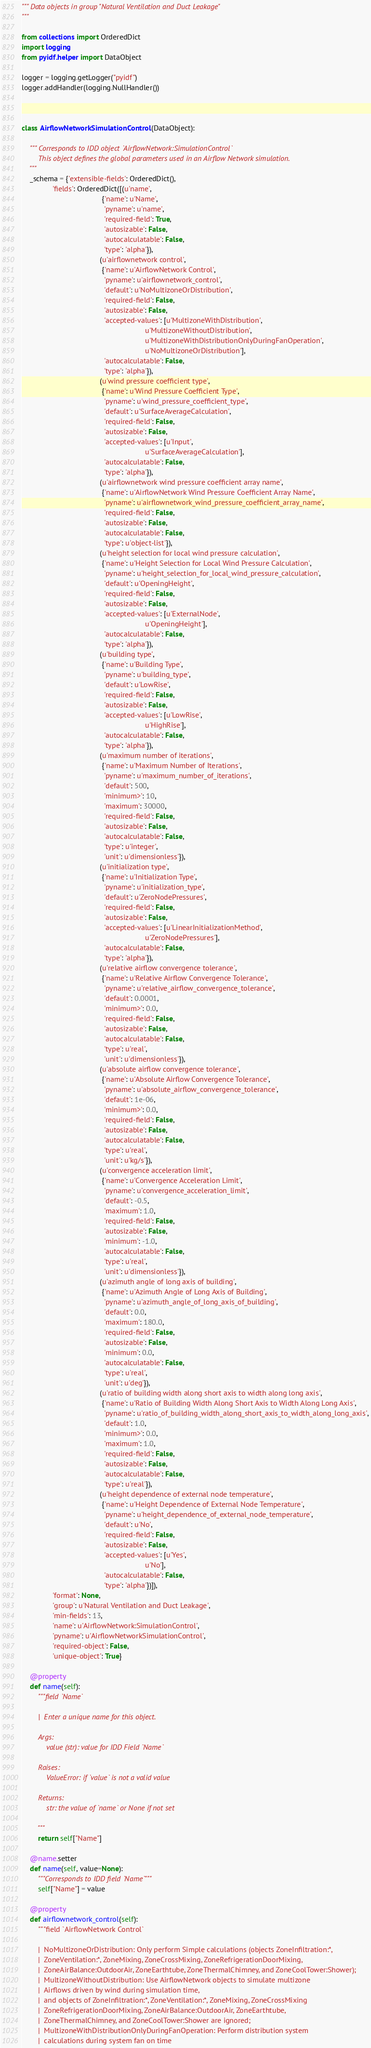<code> <loc_0><loc_0><loc_500><loc_500><_Python_>""" Data objects in group "Natural Ventilation and Duct Leakage"
"""

from collections import OrderedDict
import logging
from pyidf.helper import DataObject

logger = logging.getLogger("pyidf")
logger.addHandler(logging.NullHandler())



class AirflowNetworkSimulationControl(DataObject):

    """ Corresponds to IDD object `AirflowNetwork:SimulationControl`
        This object defines the global parameters used in an Airflow Network simulation.
    """
    _schema = {'extensible-fields': OrderedDict(),
               'fields': OrderedDict([(u'name',
                                       {'name': u'Name',
                                        'pyname': u'name',
                                        'required-field': True,
                                        'autosizable': False,
                                        'autocalculatable': False,
                                        'type': 'alpha'}),
                                      (u'airflownetwork control',
                                       {'name': u'AirflowNetwork Control',
                                        'pyname': u'airflownetwork_control',
                                        'default': u'NoMultizoneOrDistribution',
                                        'required-field': False,
                                        'autosizable': False,
                                        'accepted-values': [u'MultizoneWithDistribution',
                                                            u'MultizoneWithoutDistribution',
                                                            u'MultizoneWithDistributionOnlyDuringFanOperation',
                                                            u'NoMultizoneOrDistribution'],
                                        'autocalculatable': False,
                                        'type': 'alpha'}),
                                      (u'wind pressure coefficient type',
                                       {'name': u'Wind Pressure Coefficient Type',
                                        'pyname': u'wind_pressure_coefficient_type',
                                        'default': u'SurfaceAverageCalculation',
                                        'required-field': False,
                                        'autosizable': False,
                                        'accepted-values': [u'Input',
                                                            u'SurfaceAverageCalculation'],
                                        'autocalculatable': False,
                                        'type': 'alpha'}),
                                      (u'airflownetwork wind pressure coefficient array name',
                                       {'name': u'AirflowNetwork Wind Pressure Coefficient Array Name',
                                        'pyname': u'airflownetwork_wind_pressure_coefficient_array_name',
                                        'required-field': False,
                                        'autosizable': False,
                                        'autocalculatable': False,
                                        'type': u'object-list'}),
                                      (u'height selection for local wind pressure calculation',
                                       {'name': u'Height Selection for Local Wind Pressure Calculation',
                                        'pyname': u'height_selection_for_local_wind_pressure_calculation',
                                        'default': u'OpeningHeight',
                                        'required-field': False,
                                        'autosizable': False,
                                        'accepted-values': [u'ExternalNode',
                                                            u'OpeningHeight'],
                                        'autocalculatable': False,
                                        'type': 'alpha'}),
                                      (u'building type',
                                       {'name': u'Building Type',
                                        'pyname': u'building_type',
                                        'default': u'LowRise',
                                        'required-field': False,
                                        'autosizable': False,
                                        'accepted-values': [u'LowRise',
                                                            u'HighRise'],
                                        'autocalculatable': False,
                                        'type': 'alpha'}),
                                      (u'maximum number of iterations',
                                       {'name': u'Maximum Number of Iterations',
                                        'pyname': u'maximum_number_of_iterations',
                                        'default': 500,
                                        'minimum>': 10,
                                        'maximum': 30000,
                                        'required-field': False,
                                        'autosizable': False,
                                        'autocalculatable': False,
                                        'type': u'integer',
                                        'unit': u'dimensionless'}),
                                      (u'initialization type',
                                       {'name': u'Initialization Type',
                                        'pyname': u'initialization_type',
                                        'default': u'ZeroNodePressures',
                                        'required-field': False,
                                        'autosizable': False,
                                        'accepted-values': [u'LinearInitializationMethod',
                                                            u'ZeroNodePressures'],
                                        'autocalculatable': False,
                                        'type': 'alpha'}),
                                      (u'relative airflow convergence tolerance',
                                       {'name': u'Relative Airflow Convergence Tolerance',
                                        'pyname': u'relative_airflow_convergence_tolerance',
                                        'default': 0.0001,
                                        'minimum>': 0.0,
                                        'required-field': False,
                                        'autosizable': False,
                                        'autocalculatable': False,
                                        'type': u'real',
                                        'unit': u'dimensionless'}),
                                      (u'absolute airflow convergence tolerance',
                                       {'name': u'Absolute Airflow Convergence Tolerance',
                                        'pyname': u'absolute_airflow_convergence_tolerance',
                                        'default': 1e-06,
                                        'minimum>': 0.0,
                                        'required-field': False,
                                        'autosizable': False,
                                        'autocalculatable': False,
                                        'type': u'real',
                                        'unit': u'kg/s'}),
                                      (u'convergence acceleration limit',
                                       {'name': u'Convergence Acceleration Limit',
                                        'pyname': u'convergence_acceleration_limit',
                                        'default': -0.5,
                                        'maximum': 1.0,
                                        'required-field': False,
                                        'autosizable': False,
                                        'minimum': -1.0,
                                        'autocalculatable': False,
                                        'type': u'real',
                                        'unit': u'dimensionless'}),
                                      (u'azimuth angle of long axis of building',
                                       {'name': u'Azimuth Angle of Long Axis of Building',
                                        'pyname': u'azimuth_angle_of_long_axis_of_building',
                                        'default': 0.0,
                                        'maximum': 180.0,
                                        'required-field': False,
                                        'autosizable': False,
                                        'minimum': 0.0,
                                        'autocalculatable': False,
                                        'type': u'real',
                                        'unit': u'deg'}),
                                      (u'ratio of building width along short axis to width along long axis',
                                       {'name': u'Ratio of Building Width Along Short Axis to Width Along Long Axis',
                                        'pyname': u'ratio_of_building_width_along_short_axis_to_width_along_long_axis',
                                        'default': 1.0,
                                        'minimum>': 0.0,
                                        'maximum': 1.0,
                                        'required-field': False,
                                        'autosizable': False,
                                        'autocalculatable': False,
                                        'type': u'real'}),
                                      (u'height dependence of external node temperature',
                                       {'name': u'Height Dependence of External Node Temperature',
                                        'pyname': u'height_dependence_of_external_node_temperature',
                                        'default': u'No',
                                        'required-field': False,
                                        'autosizable': False,
                                        'accepted-values': [u'Yes',
                                                            u'No'],
                                        'autocalculatable': False,
                                        'type': 'alpha'})]),
               'format': None,
               'group': u'Natural Ventilation and Duct Leakage',
               'min-fields': 13,
               'name': u'AirflowNetwork:SimulationControl',
               'pyname': u'AirflowNetworkSimulationControl',
               'required-object': False,
               'unique-object': True}

    @property
    def name(self):
        """field `Name`

        |  Enter a unique name for this object.

        Args:
            value (str): value for IDD Field `Name`

        Raises:
            ValueError: if `value` is not a valid value

        Returns:
            str: the value of `name` or None if not set

        """
        return self["Name"]

    @name.setter
    def name(self, value=None):
        """Corresponds to IDD field `Name`"""
        self["Name"] = value

    @property
    def airflownetwork_control(self):
        """field `AirflowNetwork Control`

        |  NoMultizoneOrDistribution: Only perform Simple calculations (objects ZoneInfiltration:*,
        |  ZoneVentilation:*, ZoneMixing, ZoneCrossMixing, ZoneRefrigerationDoorMixing,
        |  ZoneAirBalance:OutdoorAir, ZoneEarthtube, ZoneThermalChimney, and ZoneCoolTower:Shower);
        |  MultizoneWithoutDistribution: Use AirflowNetwork objects to simulate multizone
        |  Airflows driven by wind during simulation time,
        |  and objects of ZoneInfiltration:*, ZoneVentilation:*, ZoneMixing, ZoneCrossMixing
        |  ZoneRefrigerationDoorMixing, ZoneAirBalance:OutdoorAir, ZoneEarthtube,
        |  ZoneThermalChimney, and ZoneCoolTower:Shower are ignored;
        |  MultizoneWithDistributionOnlyDuringFanOperation: Perform distribution system
        |  calculations during system fan on time</code> 